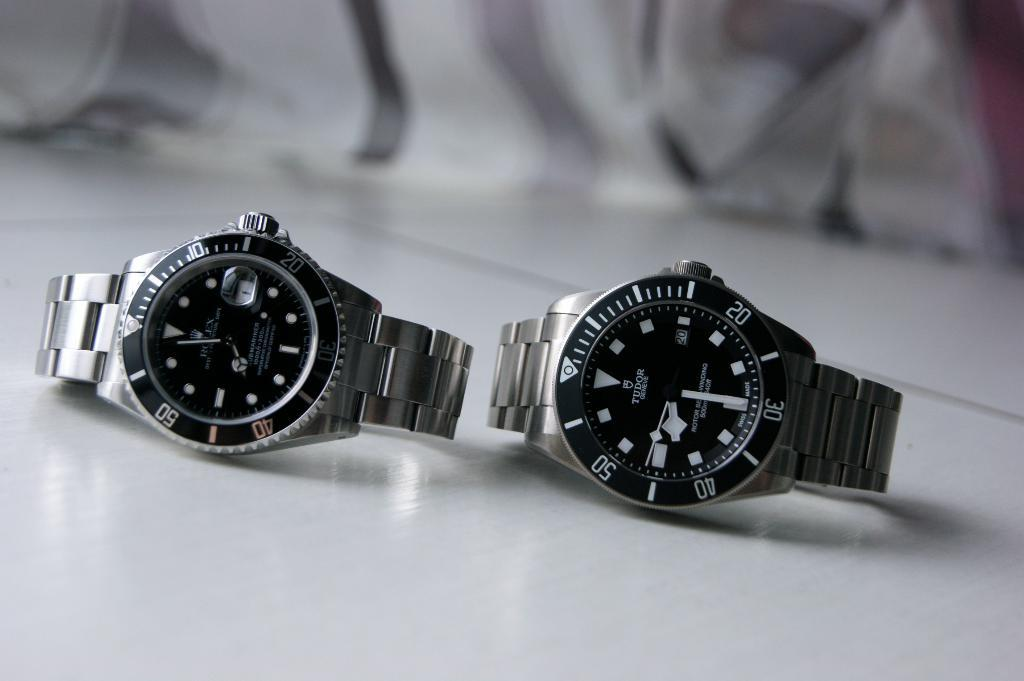<image>
Describe the image concisely. Two watches, a Rolex and a Tudor, sit on display. 